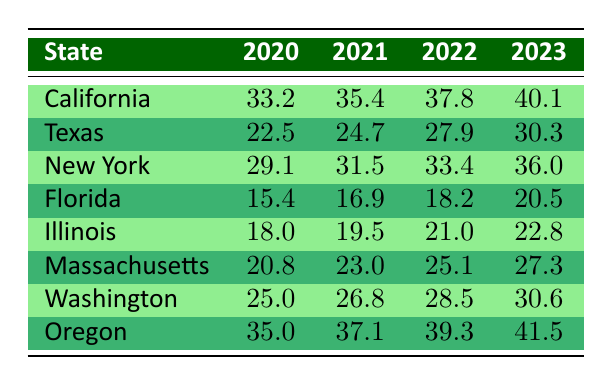What was the renewable energy adoption rate in California in 2021? The table shows that California had a renewable energy adoption rate of 35.4% in 2021.
Answer: 35.4 Which state had the highest adoption rate in 2023? Referring to the table, California had an adoption rate of 40.1% in 2023, which is the highest among all listed states.
Answer: California What is the average renewable energy adoption rate in New York from 2020 to 2023? To find the average, add the rates for New York from 2020 to 2023: (29.1 + 31.5 + 33.4 + 36.0) = 130.0. Then divide by 4 (the number of years): 130.0 / 4 = 32.5.
Answer: 32.5 Did any state have a renewable energy adoption rate below 20% in 2022? The table shows that in 2022, both Florida (18.2%) and Illinois (21.0%) had adoption rates, and only Florida's was below 20%.
Answer: Yes How much did Texas's renewable energy adoption rate increase from 2020 to 2023? Texas's adoption rate in 2020 was 22.5%, and in 2023 it was 30.3%. The increase is 30.3 - 22.5 = 7.8.
Answer: 7.8 